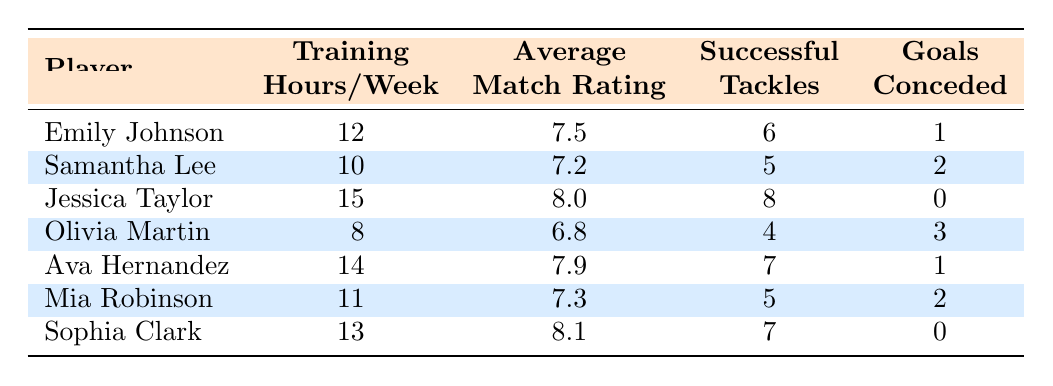What is the highest average match rating among the players? By looking at the "Average Match Rating" column, we can see that the highest rating is 8.1, which belongs to Sophia Clark.
Answer: 8.1 Which player had the fewest goals conceded? The "Goals Conceded" column shows that Jessica Taylor and Sophia Clark both conceded 0 goals, indicating they had the fewest.
Answer: Jessica Taylor and Sophia Clark How many successful tackles did Ava Hernandez achieve? Referring to the "Successful Tackles" column, Ava Hernandez has a total of 7 successful tackles.
Answer: 7 What is the average number of training hours per week among all players? To find the average, we sum the training hours (12 + 10 + 15 + 8 + 14 + 11 + 13 = 93) and divide by the number of players (7), resulting in an average of 93/7 = 13.29.
Answer: 13.29 Is it true that Emily Johnson trained more hours than Olivia Martin? A comparison of the "Training Hours/Week" shows Emily Johnson with 12 hours and Olivia Martin with 8 hours, confirming the statement is true.
Answer: Yes Which player has the most successful tackles and how many did they achieve? By reviewing the "Successful Tackles" column, we can see that Jessica Taylor has the most successful tackles at 8.
Answer: Jessica Taylor, 8 If we consider only the players who trained for more than 12 hours, what is the average match rating of those players? The players training more than 12 hours are Jessica Taylor (8.0), Ava Hernandez (7.9), and Sophia Clark (8.1). The average is calculated as (8.0 + 7.9 + 8.1) / 3 = 8.0.
Answer: 8.0 What is the relationship between training hours and the average match rating based on this table? From the table, as training hours increase, the average match rating tends to also increase, suggesting a positive correlation.
Answer: Positive correlation Which player is most likely to have the best defensive impact based on successful tackles and goals conceded? Jessica Taylor had the highest successful tackles (8) and conceded 0 goals, indicating a strong defensive impact.
Answer: Jessica Taylor 